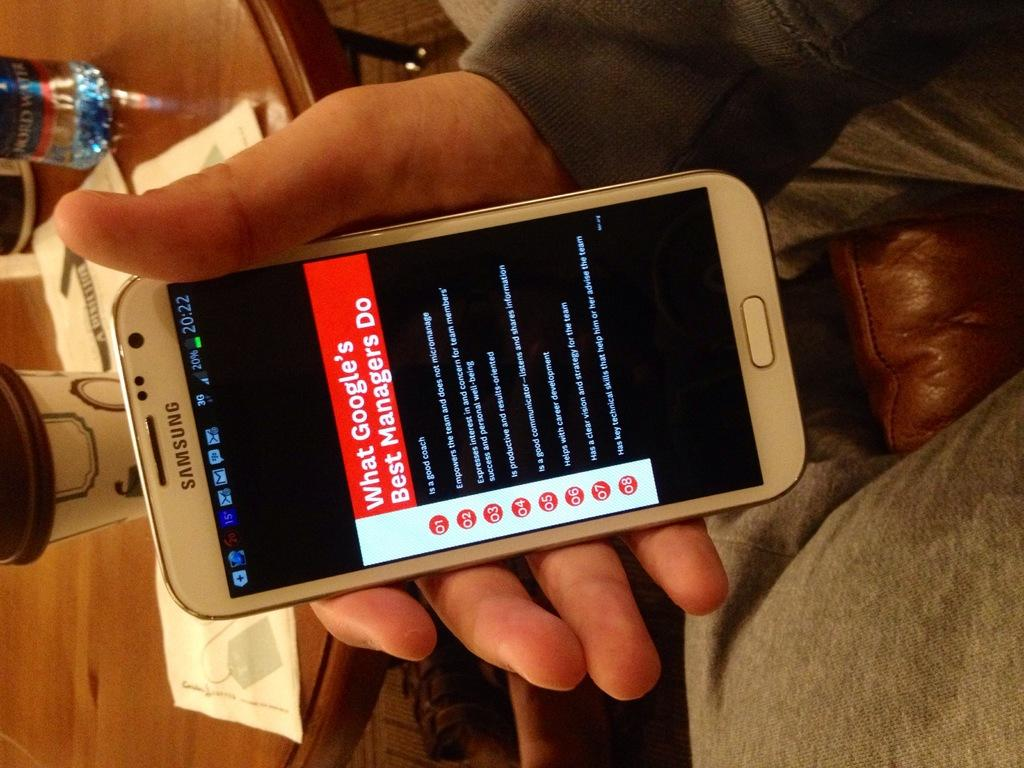Provide a one-sentence caption for the provided image. White Samsung phone home screen showing " What Googles Best Managers Do". 